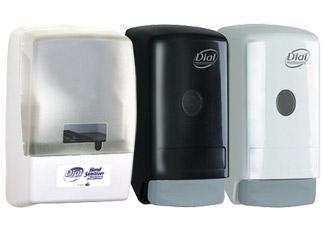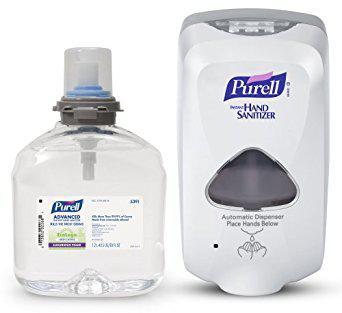The first image is the image on the left, the second image is the image on the right. Evaluate the accuracy of this statement regarding the images: "in at least one image there are three wall soap dispensers.". Is it true? Answer yes or no. Yes. The first image is the image on the left, the second image is the image on the right. Assess this claim about the two images: "An image shows exactly three dispensers in a row, with at least two of them the same style.". Correct or not? Answer yes or no. Yes. 